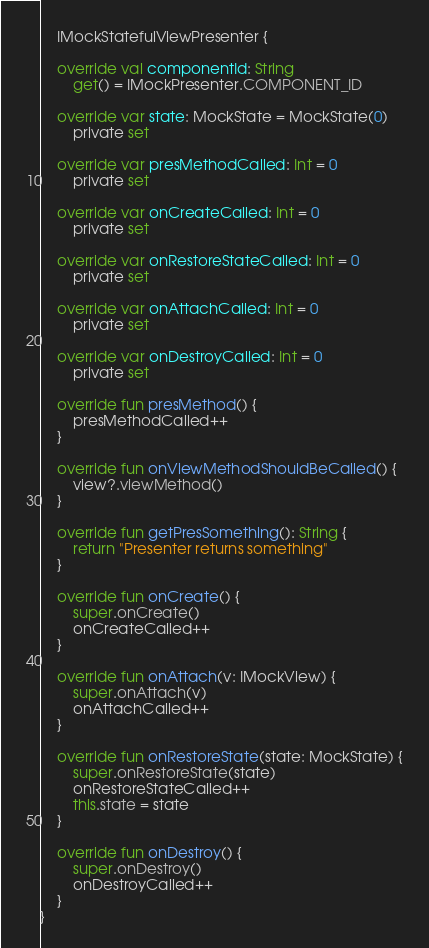<code> <loc_0><loc_0><loc_500><loc_500><_Kotlin_>    IMockStatefulViewPresenter {

    override val componentId: String
        get() = IMockPresenter.COMPONENT_ID

    override var state: MockState = MockState(0)
        private set

    override var presMethodCalled: Int = 0
        private set

    override var onCreateCalled: Int = 0
        private set

    override var onRestoreStateCalled: Int = 0
        private set

    override var onAttachCalled: Int = 0
        private set

    override var onDestroyCalled: Int = 0
        private set

    override fun presMethod() {
        presMethodCalled++
    }

    override fun onViewMethodShouldBeCalled() {
        view?.viewMethod()
    }

    override fun getPresSomething(): String {
        return "Presenter returns something"
    }

    override fun onCreate() {
        super.onCreate()
        onCreateCalled++
    }

    override fun onAttach(v: IMockView) {
        super.onAttach(v)
        onAttachCalled++
    }

    override fun onRestoreState(state: MockState) {
        super.onRestoreState(state)
        onRestoreStateCalled++
        this.state = state
    }

    override fun onDestroy() {
        super.onDestroy()
        onDestroyCalled++
    }
}</code> 